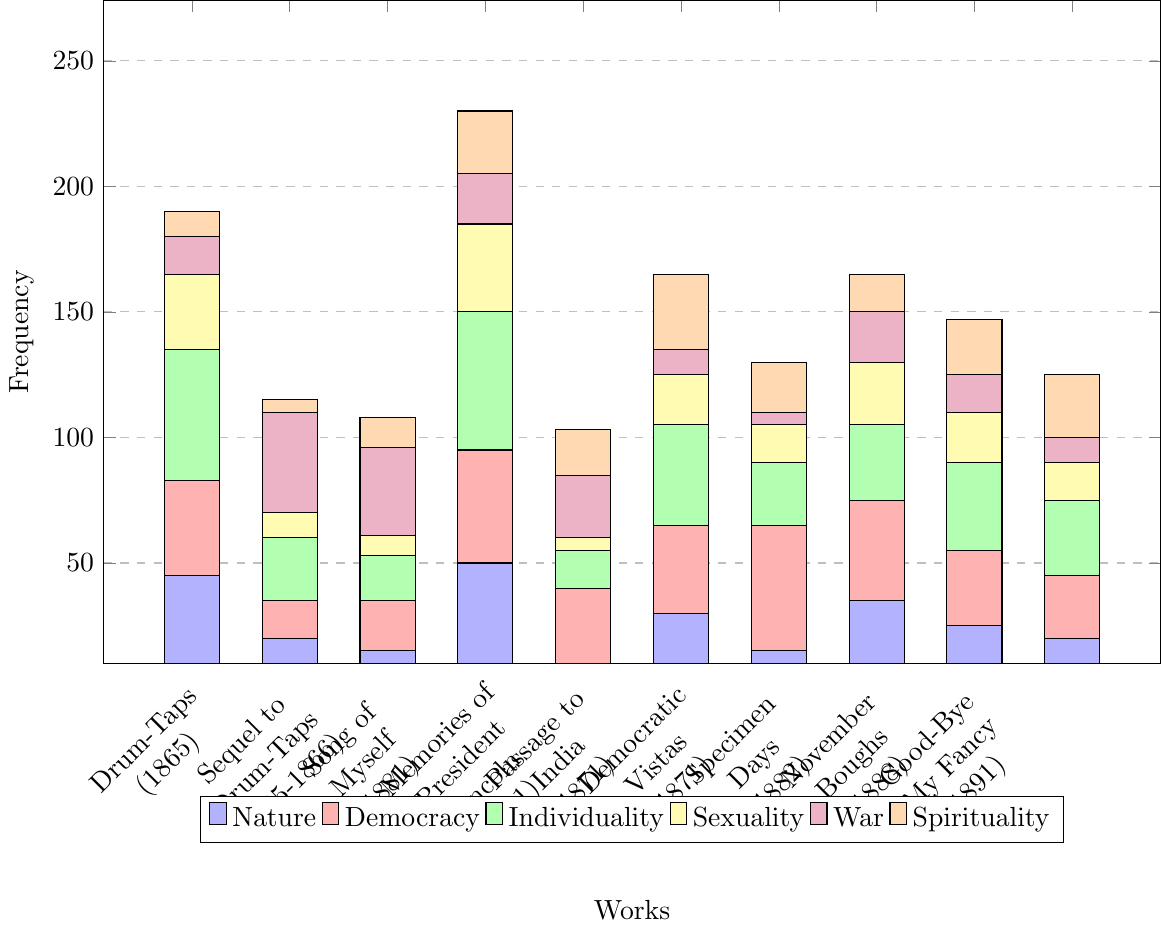What is the most frequently recurring theme in "Leaves of Grass (1855)"? Identify the bar with the greatest height for "Leaves of Grass (1855)". The tallest bar represents Individuality.
Answer: Individuality Which work has the highest frequency of the War theme? Find the tallest purple bar in the chart, which represents the War theme. The bar for "Drum-Taps (1865)" is the tallest.
Answer: Drum-Taps (1865) How many more times does the theme of Sexuality appear in "Song of Myself (1881)" compared to "Sequel to Drum-Taps (1865-1866)"? Locate the yellow bars for both "Song of Myself (1881)" and "Sequel to Drum-Taps (1865-1866)". The heights are 35 and 8 respectively. The difference is 35 - 8.
Answer: 27 Which work has the lowest frequency of the Spirituality theme? Identify the shortest orange bar on the chart, which represents the Spirituality theme. The shortest bar is for "Drum-Taps (1865)".
Answer: Drum-Taps (1865) What is the combined frequency of the Nature and Democracy themes in "Passage to India (1871)"? Add the heights of the blue and red bars for "Passage to India (1871)". They are 30 and 35. The sum is 30 + 35.
Answer: 65 Is the frequency of Individuality in "November Boughs (1888)" greater than the frequency of Democracy in "Leaves of Grass (1855)"? Compare the heights of the green bar for "November Boughs (1888)" and the red bar for "Leaves of Grass (1855)". The heights are 35 and 38 respectively.
Answer: No Which theme has the highest frequency across all works for "Specimen Days (1882)"? Identify the color of the tallest bar for "Specimen Days (1882)". The tallest bar is red, representing Democracy.
Answer: Democracy What is the average frequency of the War theme across all works? Sum the heights of all purple bars and divide by the number of works. The heights are 15, 40, 35, 20, 25, 10, 5, 20, 15, 10. The total is 195, and there are 10 works. The average is 195 / 10.
Answer: 19.5 By how much does the frequency of Nature in "Leaves of Grass (1855)" exceed the frequency of Nature in "Memories of President Lincoln (1881)"? Locate the blue bars for both "Leaves of Grass (1855)" and "Memories of President Lincoln (1881)". The heights are 45 and 10 respectively. The difference is 45 - 10.
Answer: 35 What is the total frequency of Sexuality and Spirituality themes in "Good-Bye My Fancy (1891)"? Add the heights of the yellow and orange bars for "Good-Bye My Fancy (1891)". They are 15 and 25. The sum is 15 + 25.
Answer: 40 